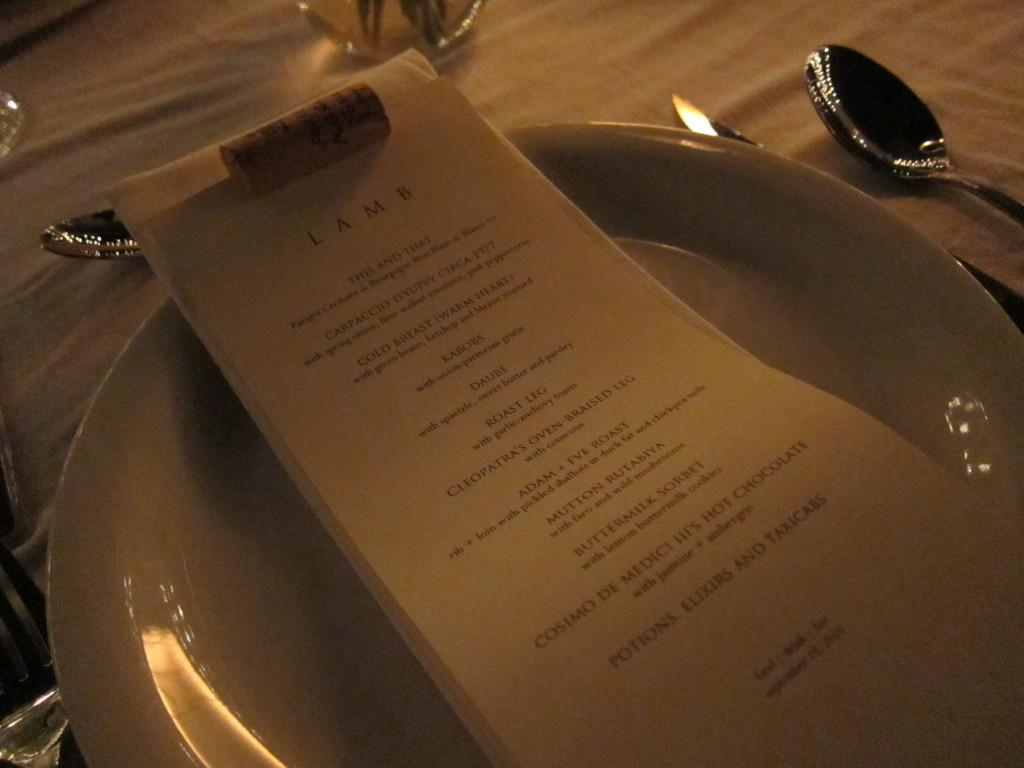What is placed on the plate in the image? There are papers on a plate in the image. Where is the plate located in the image? The plate is in the center of the image. What other objects can be seen at the top side of the image? There are spoons and other objects at the top side of the image. What type of roof can be seen in the image? There is no roof present in the image. Can you tell me how many animals are in the zoo in the image? There is no zoo present in the image. 